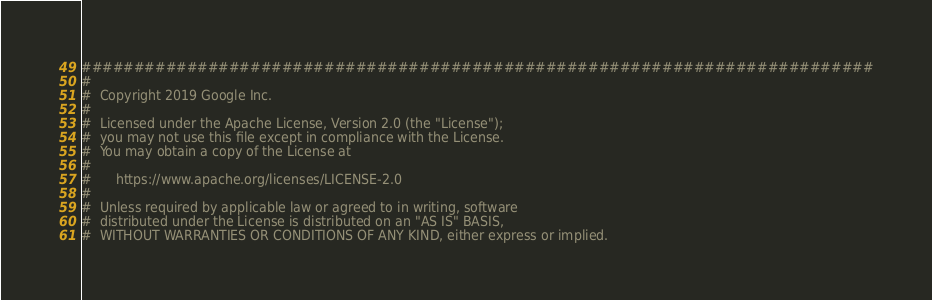Convert code to text. <code><loc_0><loc_0><loc_500><loc_500><_Python_>###########################################################################
# 
#  Copyright 2019 Google Inc.
#
#  Licensed under the Apache License, Version 2.0 (the "License");
#  you may not use this file except in compliance with the License.
#  You may obtain a copy of the License at
#
#      https://www.apache.org/licenses/LICENSE-2.0
#
#  Unless required by applicable law or agreed to in writing, software
#  distributed under the License is distributed on an "AS IS" BASIS,
#  WITHOUT WARRANTIES OR CONDITIONS OF ANY KIND, either express or implied.</code> 